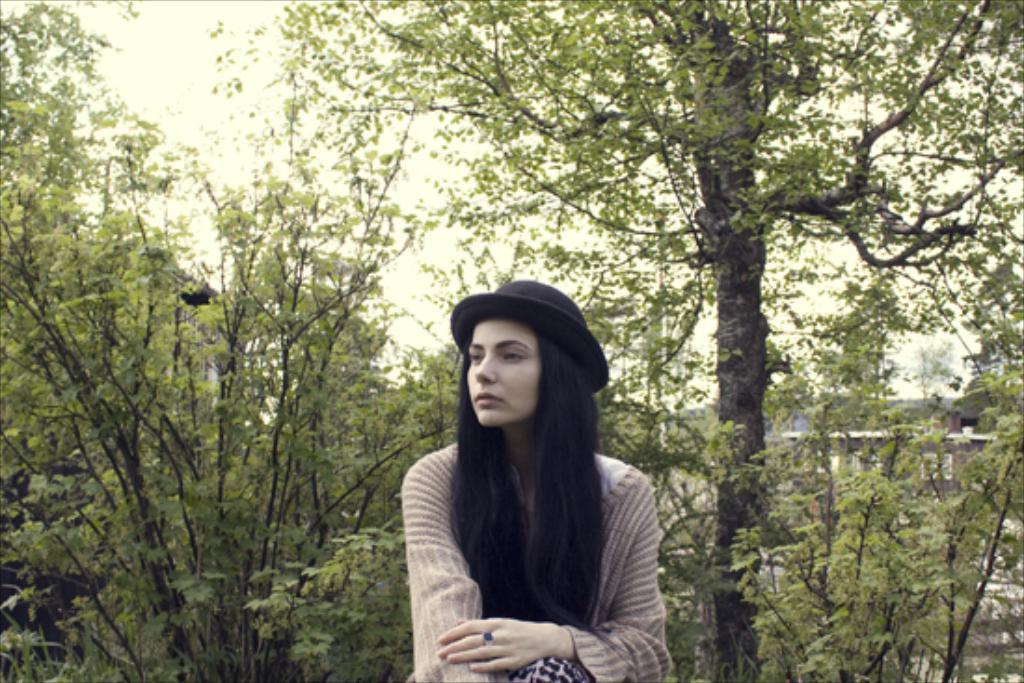How would you summarize this image in a sentence or two? In this image, I can see a woman. There are trees and I can see a house. In the background, I can see the sky. 